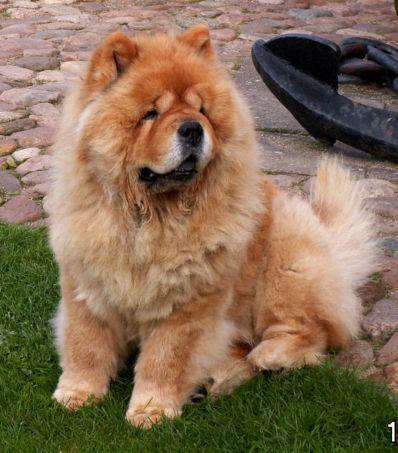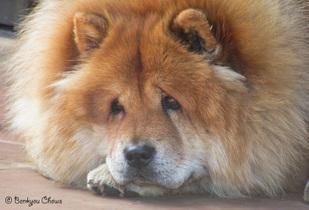The first image is the image on the left, the second image is the image on the right. For the images displayed, is the sentence "The right image contains at least two chow dogs." factually correct? Answer yes or no. No. The first image is the image on the left, the second image is the image on the right. For the images shown, is this caption "There are at most two dogs." true? Answer yes or no. Yes. 